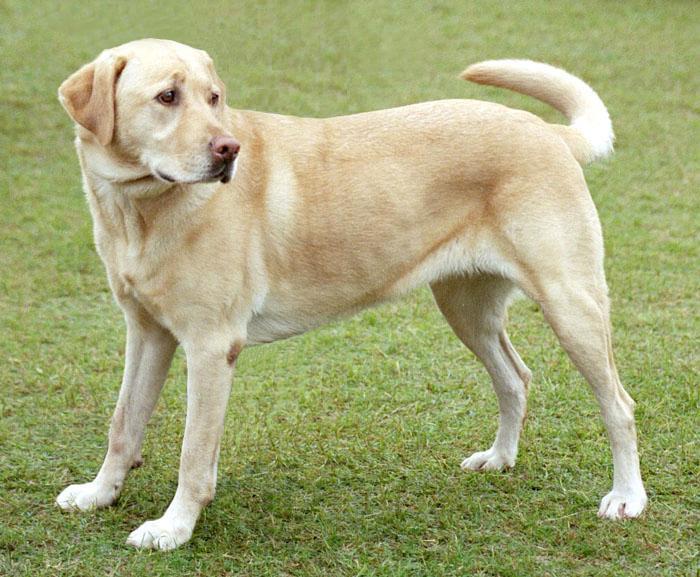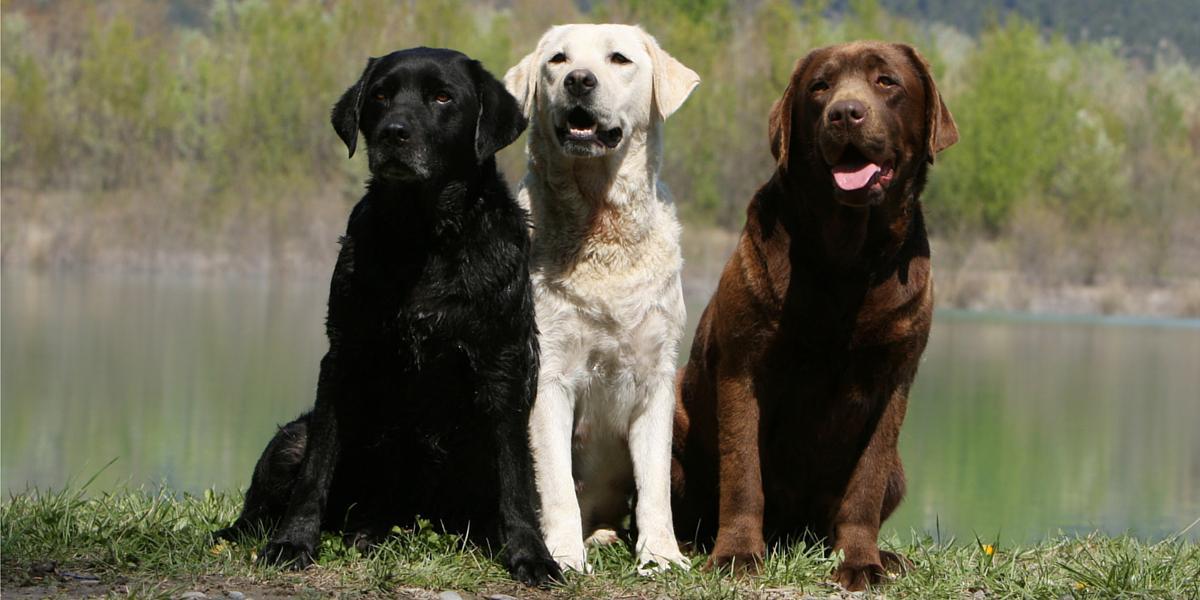The first image is the image on the left, the second image is the image on the right. For the images displayed, is the sentence "One image shows exactly three dogs, each a different color." factually correct? Answer yes or no. Yes. 